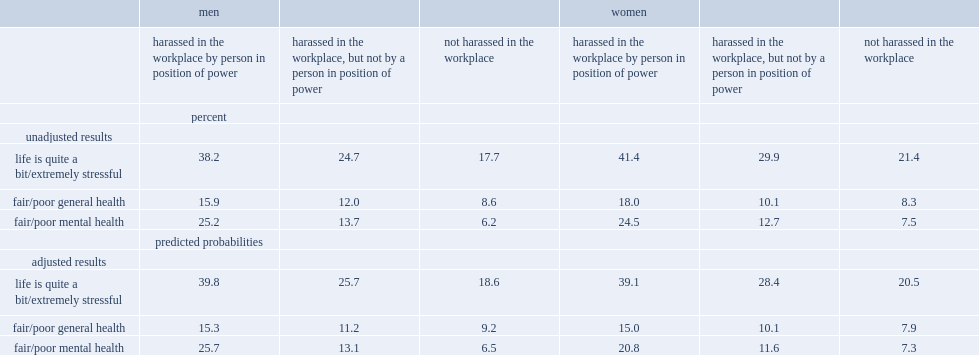What were the percentages of men who reported that they had been harassed by a person in a position of power had poor mental health and those had been harassed by someone else respectively? 25.2 13.7. 